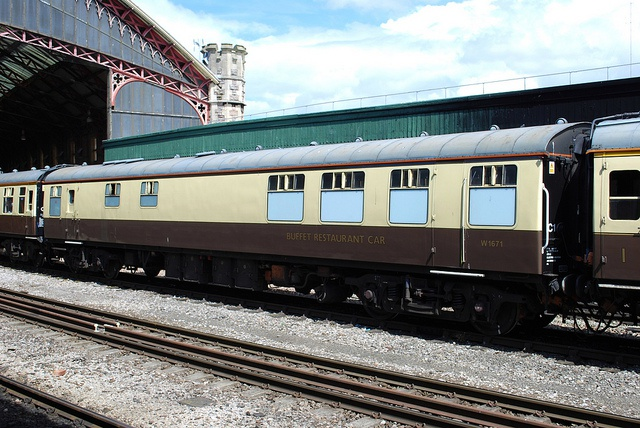Describe the objects in this image and their specific colors. I can see a train in gray, black, beige, lightgray, and lightblue tones in this image. 